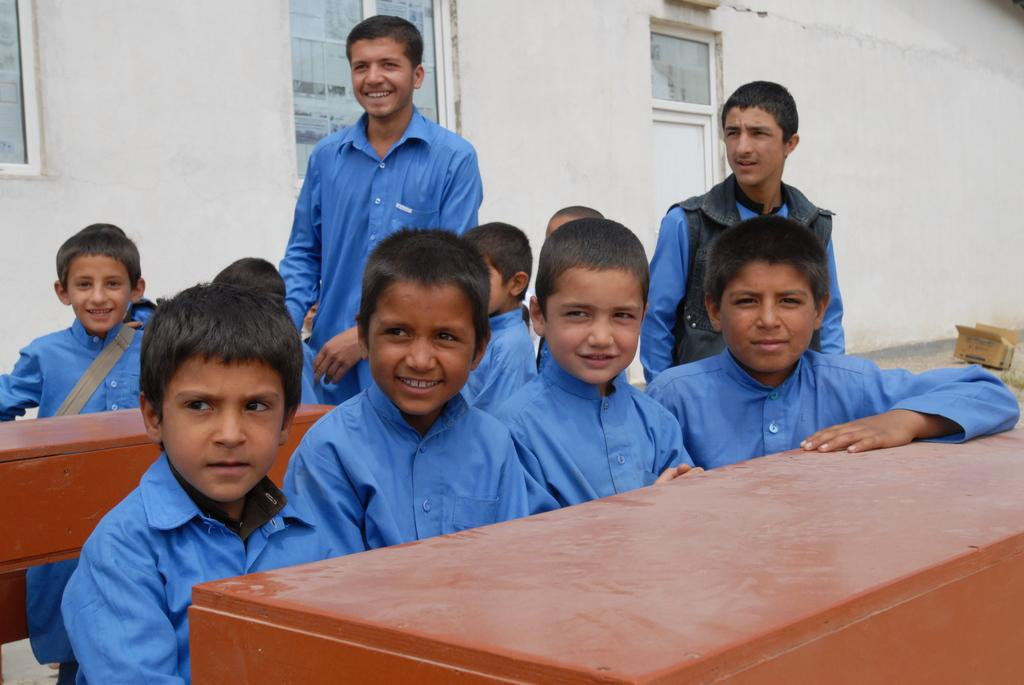How many people are in the image? There is a group of people in the image, but the exact number is not specified. What are the people doing in the image? Some people are sitting, while others are standing, and they are gathered around tables. What can be seen through the windows in the image? The information provided does not specify what can be seen through the windows. Where is the door located in the image? There is a door in the image, but its exact location is not specified. What is the purpose of the cardboard box in the image? The purpose of the cardboard box is not specified in the provided facts. What type of knee surgery is being performed on the person in the image? There is no person undergoing knee surgery in the image; it features a group of people gathered around tables. What type of iron is being used to press the clothes in the image? There is no iron or clothes-pressing activity depicted in the image. 